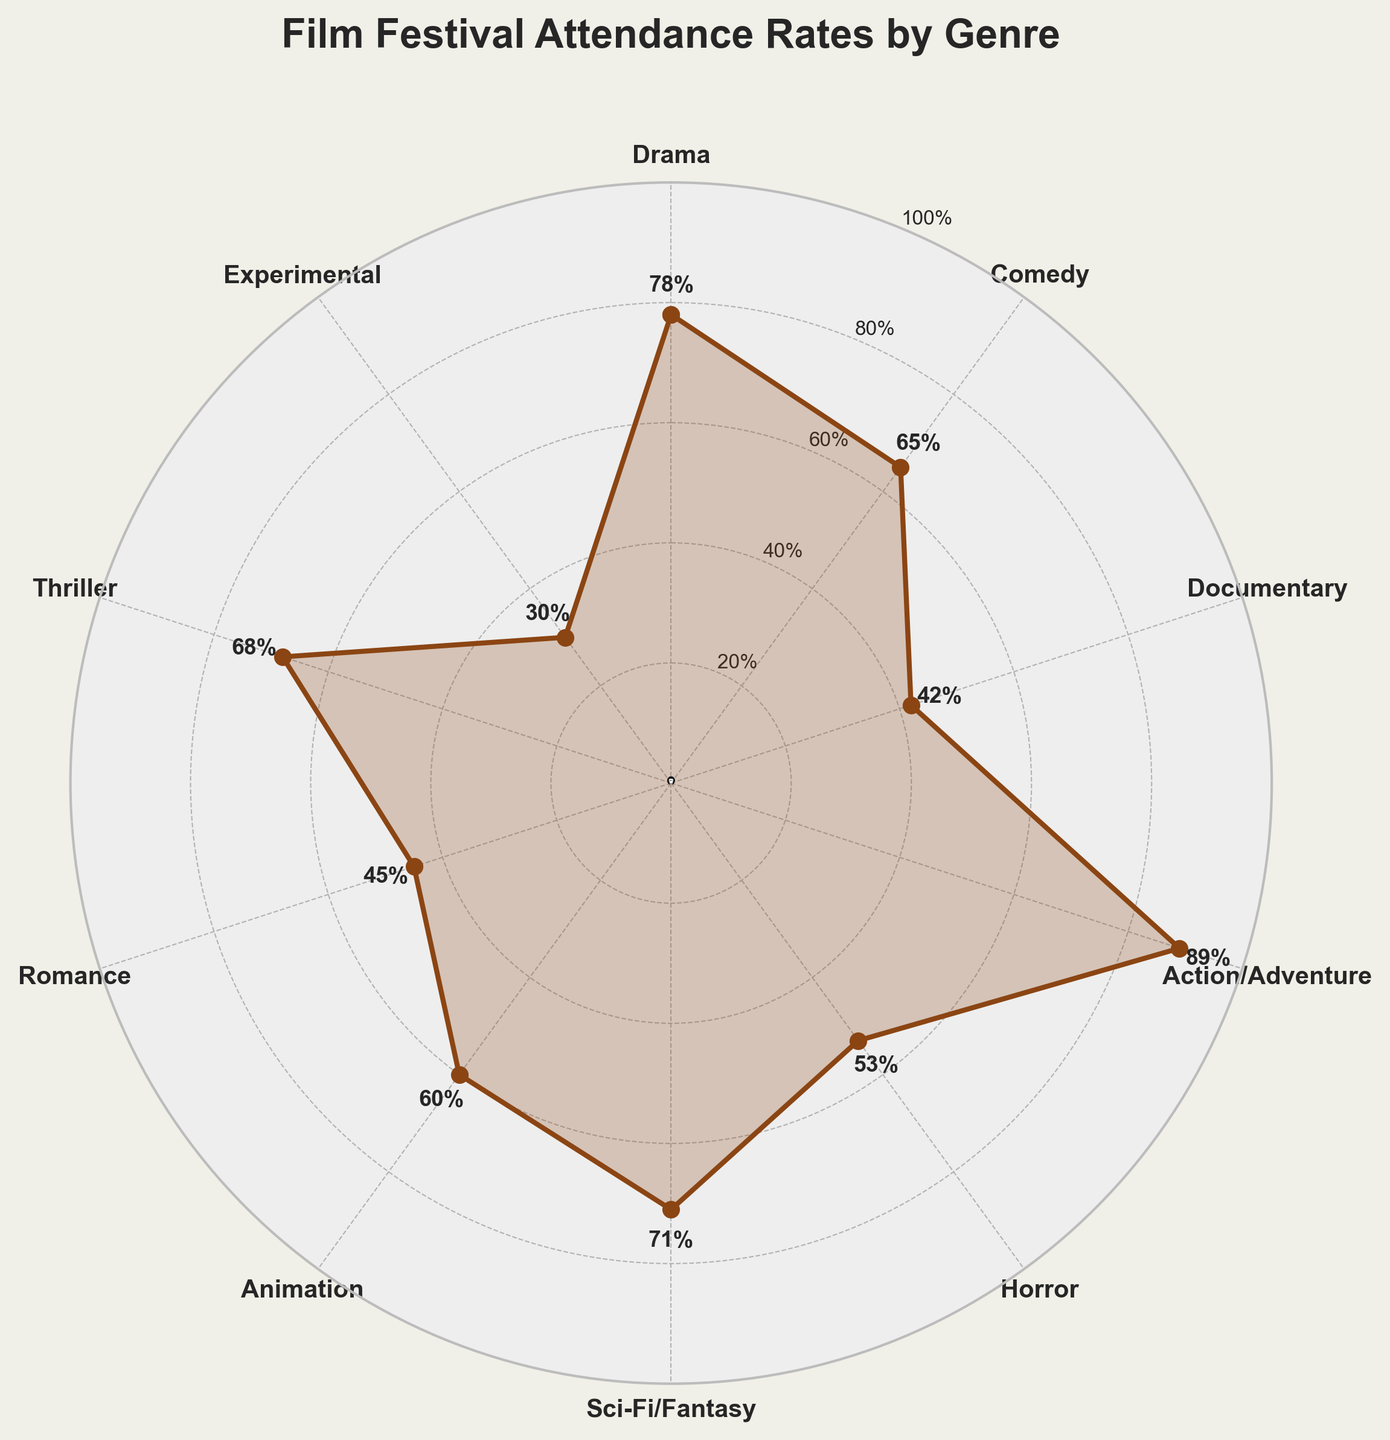what is the highest attendance rate? The highest attendance rate can be identified by looking for the largest value on the radial plot. According to the figure, Action/Adventure has the highest rate at 89%.
Answer: 89% which genre has the lowest attendance rate? To find the genre with the lowest attendance rate, look for the smallest value in the plot. The plot shows Experimental with the lowest rate at 30%.
Answer: Experimental how many genres have attendance rates above 70%? First, identify all data points above 70% in the plot. These are Drama (78%), Action/Adventure (89%), and Sci-Fi/Fantasy (71%). Hence, there are 3 genres above 70%.
Answer: 3 compare the attendance rates for Comedy and Horror. Which has a higher rate, and by how much? Identify the attendance rates for Comedy (65%) and Horror (53%). The difference is 65% - 53% = 12%, so Comedy is higher by 12%.
Answer: Comedy by 12% what is the average attendance rate across all genres? Add all attendance rates: 78 + 65 + 42 + 89 + 53 + 71 + 60 + 45 + 68 + 30 = 601. Divide by the number of genres, which is 10. The average is 601/10 = 60.1%.
Answer: 60.1% which genres fall below the average attendance rate? The average attendance rate is 60.1%. Identify genres with rates below 60.1%: Documentary (42%), Horror (53%), Romance (45%), Experimental (30%).
Answer: Documentary, Horror, Romance, Experimental what is the median attendance rate for the genres displayed? Order the rates: 30, 42, 45, 53, 60, 65, 68, 71, 78, 89. The middle values are 60 and 65. The median is (60+65)/2 = 62.5%.
Answer: 62.5% between Sci-Fi/Fantasy and Romance, which genre has a higher attendance rate and by how much? Sci-Fi/Fantasy has an attendance rate of 71% while Romance has 45%. The difference is 71% - 45% = 26%, so Sci-Fi/Fantasy is higher by 26%.
Answer: Sci-Fi/Fantasy by 26% what percentage of genres have attendance rates greater than 50%? Identify genres above 50%: Drama, Comedy, Action/Adventure, Sci-Fi/Fantasy, Animation, Thriller. There are 6 out of 10 genres, so (6/10) * 100% = 60%.
Answer: 60% identify the genre closest to the average attendance rate. The average attendance rate is 60.1%. Compare it with all genres: Animation (60%) is the closest to the average.
Answer: Animation 